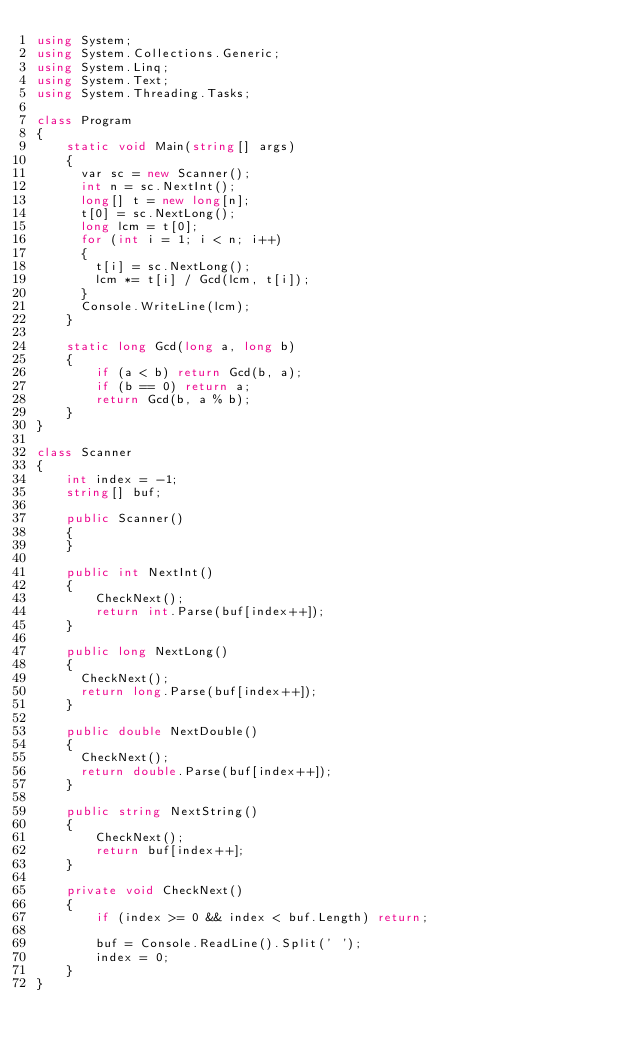<code> <loc_0><loc_0><loc_500><loc_500><_C#_>using System;
using System.Collections.Generic;
using System.Linq;
using System.Text;
using System.Threading.Tasks;

class Program
{
    static void Main(string[] args)
    {
    	var sc = new Scanner();
    	int n = sc.NextInt();
    	long[] t = new long[n];
    	t[0] = sc.NextLong();
    	long lcm = t[0];
    	for (int i = 1; i < n; i++)
    	{
    		t[i] = sc.NextLong();
    		lcm *= t[i] / Gcd(lcm, t[i]);
    	}
    	Console.WriteLine(lcm);
    }
    
    static long Gcd(long a, long b)
    {
        if (a < b) return Gcd(b, a);
        if (b == 0) return a;
        return Gcd(b, a % b);
    }
}

class Scanner
{
    int index = -1;
    string[] buf;

    public Scanner()
    {
    }

    public int NextInt()
    {
        CheckNext();
        return int.Parse(buf[index++]);
    }
        
    public long NextLong()
    {
    	CheckNext();
    	return long.Parse(buf[index++]);
    }
    
    public double NextDouble()
    {
    	CheckNext();
    	return double.Parse(buf[index++]);
    }

    public string NextString()
    {
        CheckNext();
        return buf[index++];
    }

    private void CheckNext()
    {
        if (index >= 0 && index < buf.Length) return;

        buf = Console.ReadLine().Split(' ');
        index = 0;
    }
}</code> 